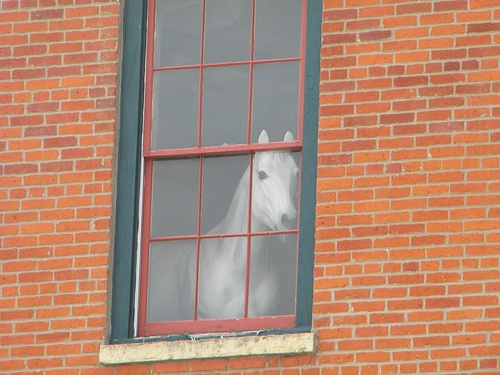Describe the objects in this image and their specific colors. I can see a horse in tan, darkgray, lightgray, brown, and lightpink tones in this image. 